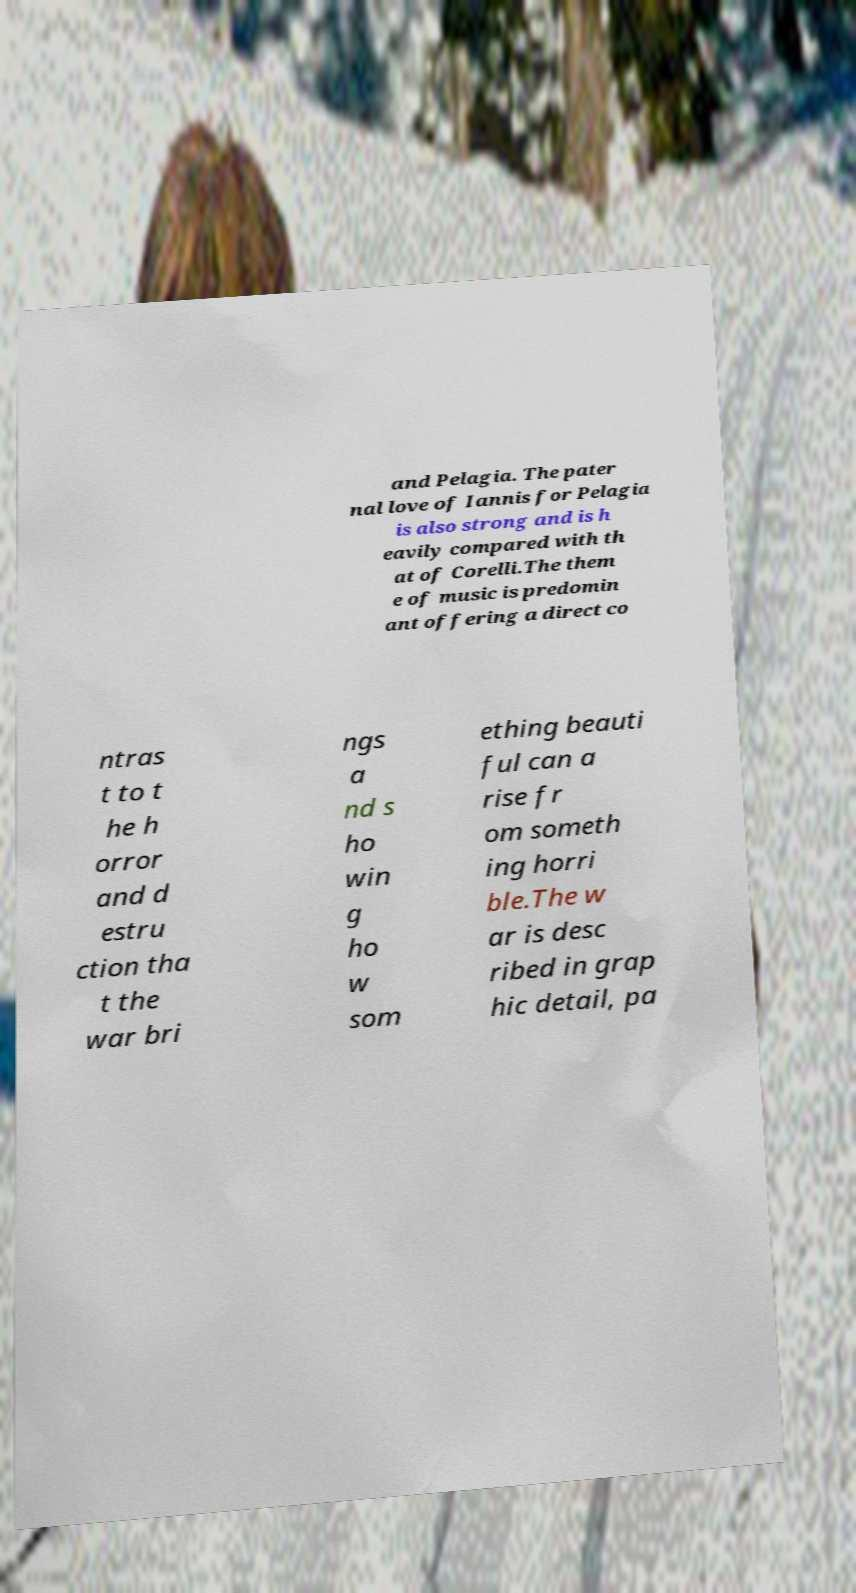Could you assist in decoding the text presented in this image and type it out clearly? and Pelagia. The pater nal love of Iannis for Pelagia is also strong and is h eavily compared with th at of Corelli.The them e of music is predomin ant offering a direct co ntras t to t he h orror and d estru ction tha t the war bri ngs a nd s ho win g ho w som ething beauti ful can a rise fr om someth ing horri ble.The w ar is desc ribed in grap hic detail, pa 